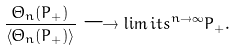<formula> <loc_0><loc_0><loc_500><loc_500>\frac { \Theta _ { n } ( P _ { + } ) } { \langle \Theta _ { n } ( P _ { + } ) \rangle } \longrightarrow \lim i t s ^ { n \rightarrow \infty } P _ { + } .</formula> 